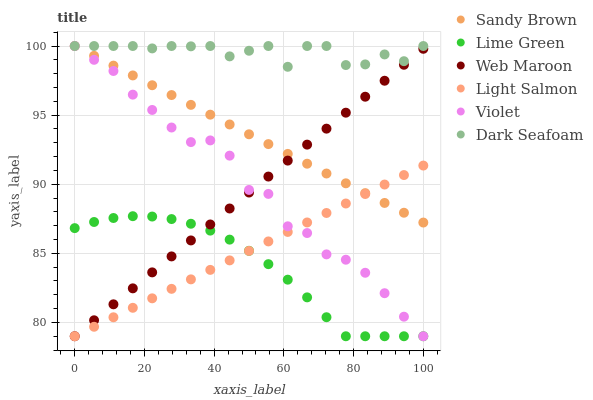Does Lime Green have the minimum area under the curve?
Answer yes or no. Yes. Does Dark Seafoam have the maximum area under the curve?
Answer yes or no. Yes. Does Sandy Brown have the minimum area under the curve?
Answer yes or no. No. Does Sandy Brown have the maximum area under the curve?
Answer yes or no. No. Is Light Salmon the smoothest?
Answer yes or no. Yes. Is Violet the roughest?
Answer yes or no. Yes. Is Sandy Brown the smoothest?
Answer yes or no. No. Is Sandy Brown the roughest?
Answer yes or no. No. Does Light Salmon have the lowest value?
Answer yes or no. Yes. Does Sandy Brown have the lowest value?
Answer yes or no. No. Does Violet have the highest value?
Answer yes or no. Yes. Does Web Maroon have the highest value?
Answer yes or no. No. Is Lime Green less than Dark Seafoam?
Answer yes or no. Yes. Is Dark Seafoam greater than Light Salmon?
Answer yes or no. Yes. Does Lime Green intersect Violet?
Answer yes or no. Yes. Is Lime Green less than Violet?
Answer yes or no. No. Is Lime Green greater than Violet?
Answer yes or no. No. Does Lime Green intersect Dark Seafoam?
Answer yes or no. No. 